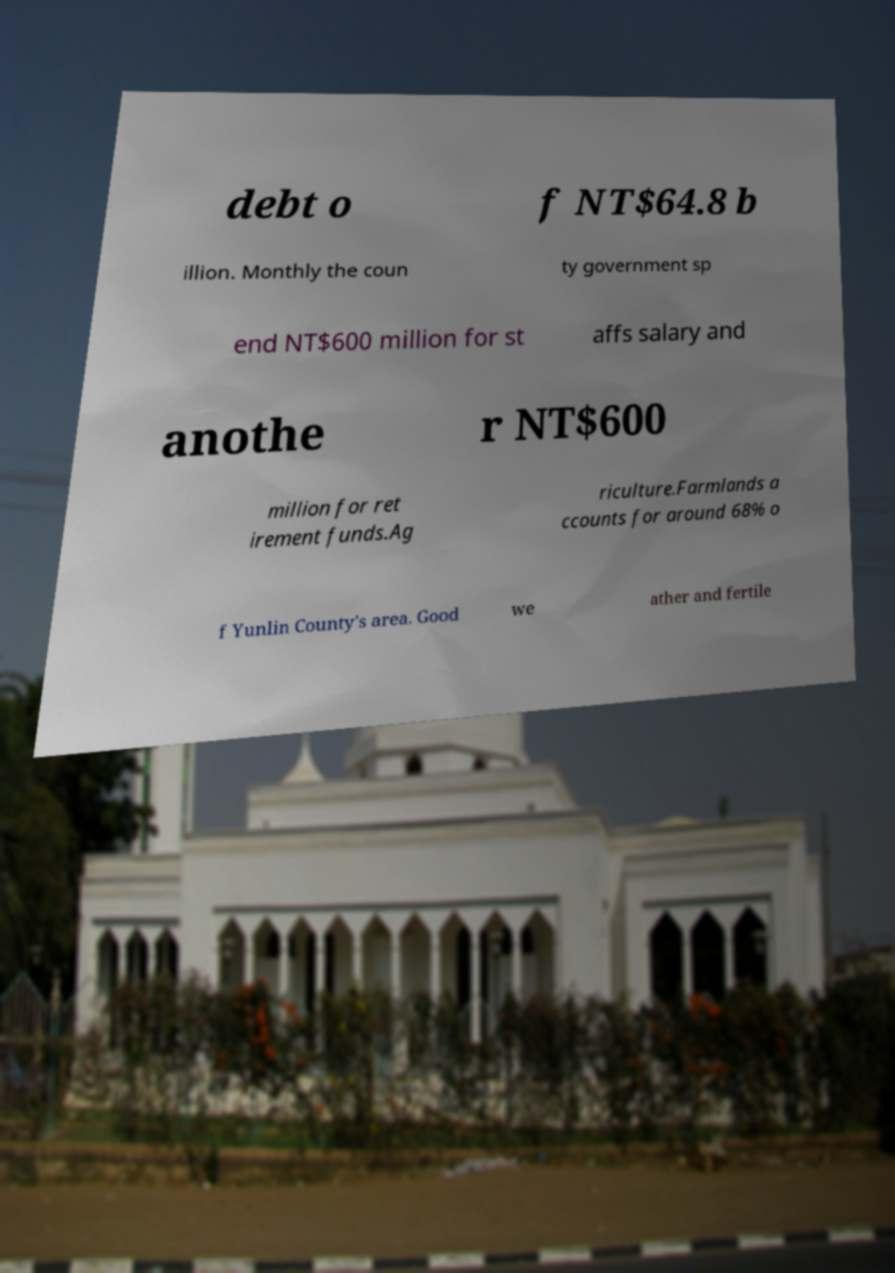What messages or text are displayed in this image? I need them in a readable, typed format. debt o f NT$64.8 b illion. Monthly the coun ty government sp end NT$600 million for st affs salary and anothe r NT$600 million for ret irement funds.Ag riculture.Farmlands a ccounts for around 68% o f Yunlin County's area. Good we ather and fertile 